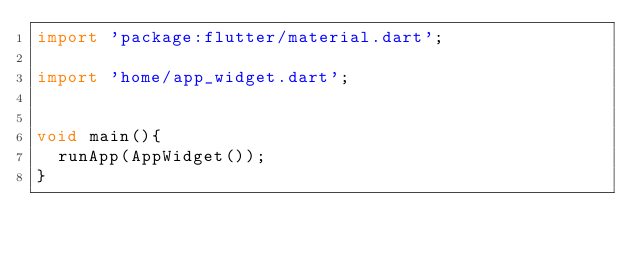Convert code to text. <code><loc_0><loc_0><loc_500><loc_500><_Dart_>import 'package:flutter/material.dart';

import 'home/app_widget.dart';


void main(){
  runApp(AppWidget());
}</code> 